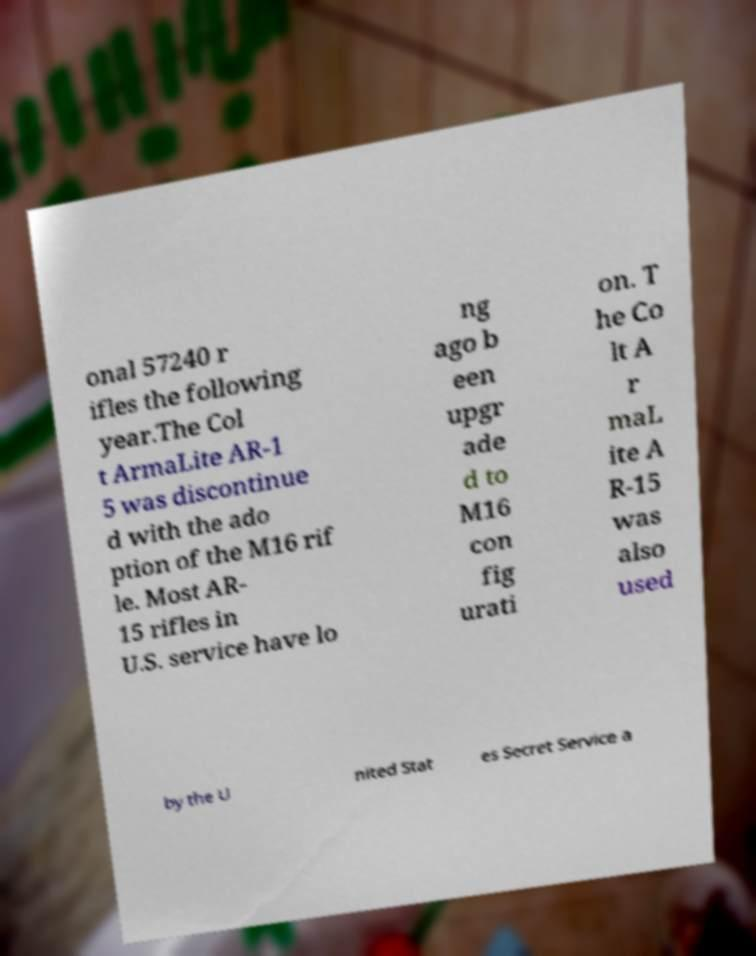Please identify and transcribe the text found in this image. onal 57240 r ifles the following year.The Col t ArmaLite AR-1 5 was discontinue d with the ado ption of the M16 rif le. Most AR- 15 rifles in U.S. service have lo ng ago b een upgr ade d to M16 con fig urati on. T he Co lt A r maL ite A R-15 was also used by the U nited Stat es Secret Service a 